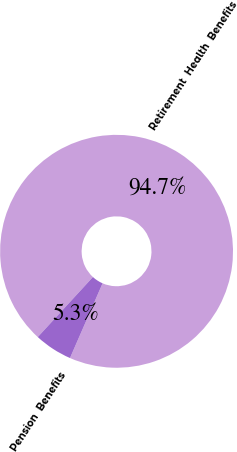Convert chart. <chart><loc_0><loc_0><loc_500><loc_500><pie_chart><fcel>Retirement  Health  Benefits<fcel>Pension  Benefits<nl><fcel>94.72%<fcel>5.28%<nl></chart> 